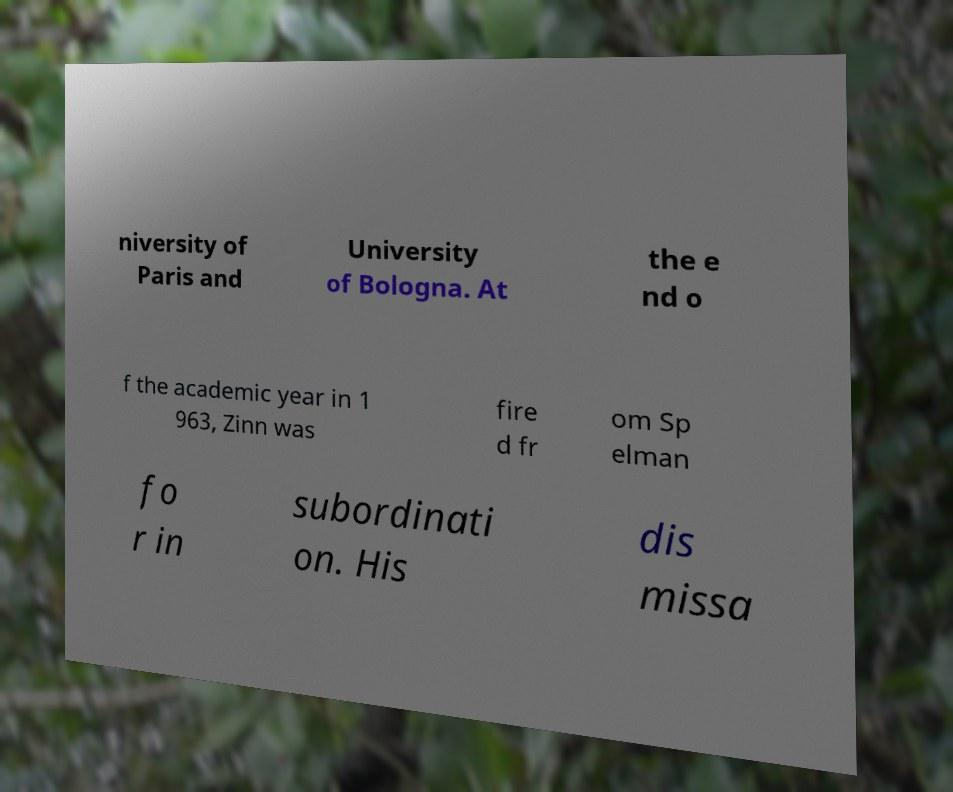I need the written content from this picture converted into text. Can you do that? niversity of Paris and University of Bologna. At the e nd o f the academic year in 1 963, Zinn was fire d fr om Sp elman fo r in subordinati on. His dis missa 